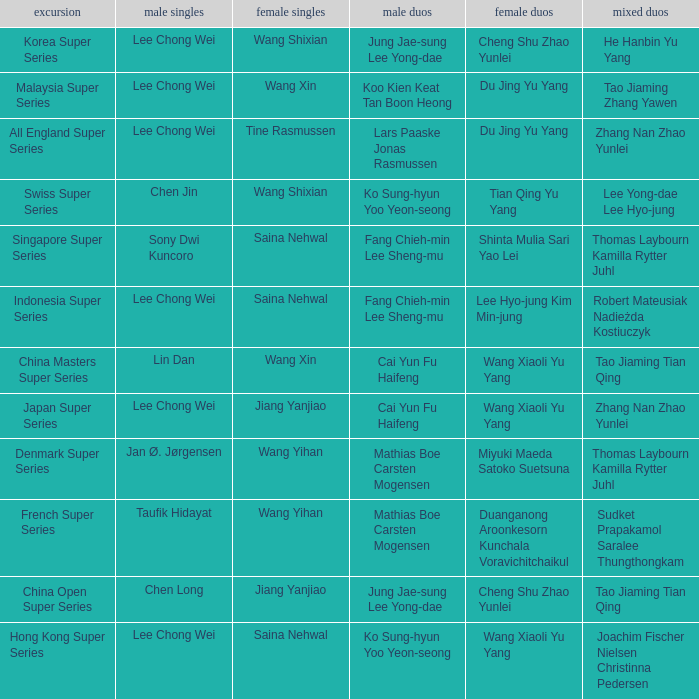Who is the women's doubles when the mixed doubles are sudket prapakamol saralee thungthongkam? Duanganong Aroonkesorn Kunchala Voravichitchaikul. Would you be able to parse every entry in this table? {'header': ['excursion', 'male singles', 'female singles', 'male duos', 'female duos', 'mixed duos'], 'rows': [['Korea Super Series', 'Lee Chong Wei', 'Wang Shixian', 'Jung Jae-sung Lee Yong-dae', 'Cheng Shu Zhao Yunlei', 'He Hanbin Yu Yang'], ['Malaysia Super Series', 'Lee Chong Wei', 'Wang Xin', 'Koo Kien Keat Tan Boon Heong', 'Du Jing Yu Yang', 'Tao Jiaming Zhang Yawen'], ['All England Super Series', 'Lee Chong Wei', 'Tine Rasmussen', 'Lars Paaske Jonas Rasmussen', 'Du Jing Yu Yang', 'Zhang Nan Zhao Yunlei'], ['Swiss Super Series', 'Chen Jin', 'Wang Shixian', 'Ko Sung-hyun Yoo Yeon-seong', 'Tian Qing Yu Yang', 'Lee Yong-dae Lee Hyo-jung'], ['Singapore Super Series', 'Sony Dwi Kuncoro', 'Saina Nehwal', 'Fang Chieh-min Lee Sheng-mu', 'Shinta Mulia Sari Yao Lei', 'Thomas Laybourn Kamilla Rytter Juhl'], ['Indonesia Super Series', 'Lee Chong Wei', 'Saina Nehwal', 'Fang Chieh-min Lee Sheng-mu', 'Lee Hyo-jung Kim Min-jung', 'Robert Mateusiak Nadieżda Kostiuczyk'], ['China Masters Super Series', 'Lin Dan', 'Wang Xin', 'Cai Yun Fu Haifeng', 'Wang Xiaoli Yu Yang', 'Tao Jiaming Tian Qing'], ['Japan Super Series', 'Lee Chong Wei', 'Jiang Yanjiao', 'Cai Yun Fu Haifeng', 'Wang Xiaoli Yu Yang', 'Zhang Nan Zhao Yunlei'], ['Denmark Super Series', 'Jan Ø. Jørgensen', 'Wang Yihan', 'Mathias Boe Carsten Mogensen', 'Miyuki Maeda Satoko Suetsuna', 'Thomas Laybourn Kamilla Rytter Juhl'], ['French Super Series', 'Taufik Hidayat', 'Wang Yihan', 'Mathias Boe Carsten Mogensen', 'Duanganong Aroonkesorn Kunchala Voravichitchaikul', 'Sudket Prapakamol Saralee Thungthongkam'], ['China Open Super Series', 'Chen Long', 'Jiang Yanjiao', 'Jung Jae-sung Lee Yong-dae', 'Cheng Shu Zhao Yunlei', 'Tao Jiaming Tian Qing'], ['Hong Kong Super Series', 'Lee Chong Wei', 'Saina Nehwal', 'Ko Sung-hyun Yoo Yeon-seong', 'Wang Xiaoli Yu Yang', 'Joachim Fischer Nielsen Christinna Pedersen']]} 